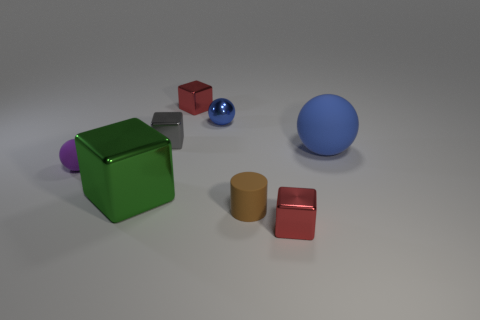Add 2 small red matte objects. How many objects exist? 10 Subtract all spheres. How many objects are left? 5 Subtract 0 gray spheres. How many objects are left? 8 Subtract all matte cylinders. Subtract all large metallic cubes. How many objects are left? 6 Add 8 small blue things. How many small blue things are left? 9 Add 4 green shiny cubes. How many green shiny cubes exist? 5 